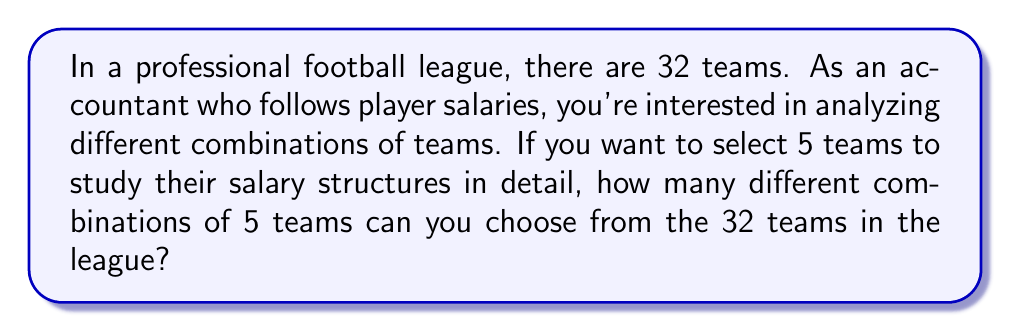Could you help me with this problem? To solve this problem, we need to use the combination formula. We are selecting 5 teams from a total of 32 teams, where the order doesn't matter (selecting Team A, then Team B is the same as selecting Team B, then Team A).

The formula for combinations is:

$$ C(n,r) = \frac{n!}{r!(n-r)!} $$

Where:
$n$ is the total number of items to choose from (in this case, 32 teams)
$r$ is the number of items being chosen (in this case, 5 teams)

Let's plug in our values:

$$ C(32,5) = \frac{32!}{5!(32-5)!} = \frac{32!}{5!27!} $$

Now, let's calculate this step-by-step:

1) First, let's calculate 32!:
   $32! = 32 \times 31 \times 30 \times 29 \times 28 \times 27!$

2) We can cancel out 27! in the numerator and denominator:
   $\frac{32 \times 31 \times 30 \times 29 \times 28}{5!}$

3) Now calculate 5!:
   $5! = 5 \times 4 \times 3 \times 2 \times 1 = 120$

4) So our equation becomes:
   $\frac{32 \times 31 \times 30 \times 29 \times 28}{120}$

5) Multiply the numerator:
   $\frac{26,978,880}{120}$

6) Divide:
   $224,824$

Therefore, there are 224,824 different combinations of 5 teams that can be chosen from the 32 teams in the league.
Answer: 224,824 